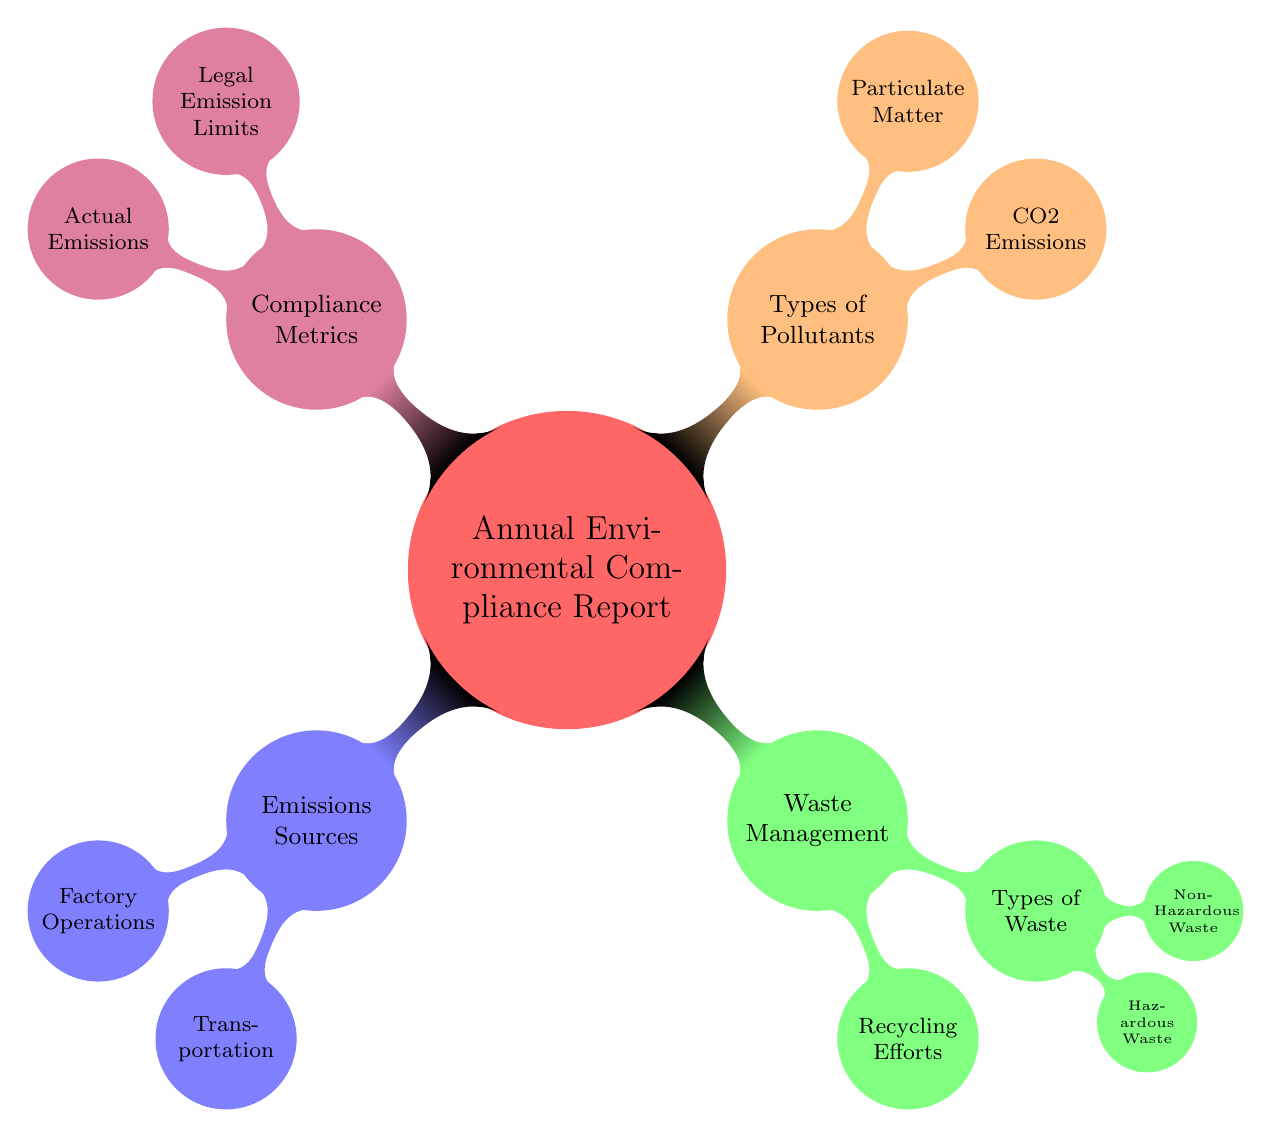What are the two primary categories of the report? The diagram illustrates that the two primary categories of the report are "Emissions Sources" and "Waste Management" as the first child nodes of the main node "Annual Environmental Compliance Report".
Answer: Emissions Sources, Waste Management How many child nodes are under "Waste Management"? The diagram shows that "Waste Management" has two child nodes: "Recycling Efforts" and "Types of Waste". Therefore, it has a total of two child nodes.
Answer: 2 What type of waste is considered hazardous? According to the diagram, "Hazardous Waste" is explicitly listed as a type of waste under the child node "Types of Waste". Thus, it is directly identifiable as hazardous.
Answer: Hazardous Waste Which type of emissions is associated with "Transportation"? The diagram does not specify the types of emissions linked to "Transportation", but as it is a child of the "Emissions Sources" node, it suggests the emissions from transportation are included under that category. Thus, the answer includes that designation.
Answer: Emissions from Transportation What is the node that shows the difference between legal limits and actual emissions? The diagram points to "Compliance Metrics", which includes two aspects: "Legal Emission Limits" and "Actual Emissions". Therefore, it indicates that this node is responsible for showcasing the difference between legal and actual emissions.
Answer: Compliance Metrics How many types of pollutants are listed in the diagram? The diagram features two types of pollutants which are listed as child nodes under "Types of Pollutants": "CO2 Emissions" and "Particulate Matter". Hence, the total count is two.
Answer: 2 Which node contains the most detailed information regarding waste? The node "Types of Waste" contains further details by breaking down waste into "Hazardous Waste" and "Non-Hazardous Waste", making it the most detailed node regarding waste in the diagram.
Answer: Types of Waste How is the report organized based on the main theme? The organization of the report is structured around the central theme of "Annual Environmental Compliance Report", branching out to multiple categories including "Emissions Sources", "Waste Management", and "Types of Pollutants". Each node then further breaks down into specifics, indicating the report's comprehensive approach.
Answer: Organized around categories and specifics 